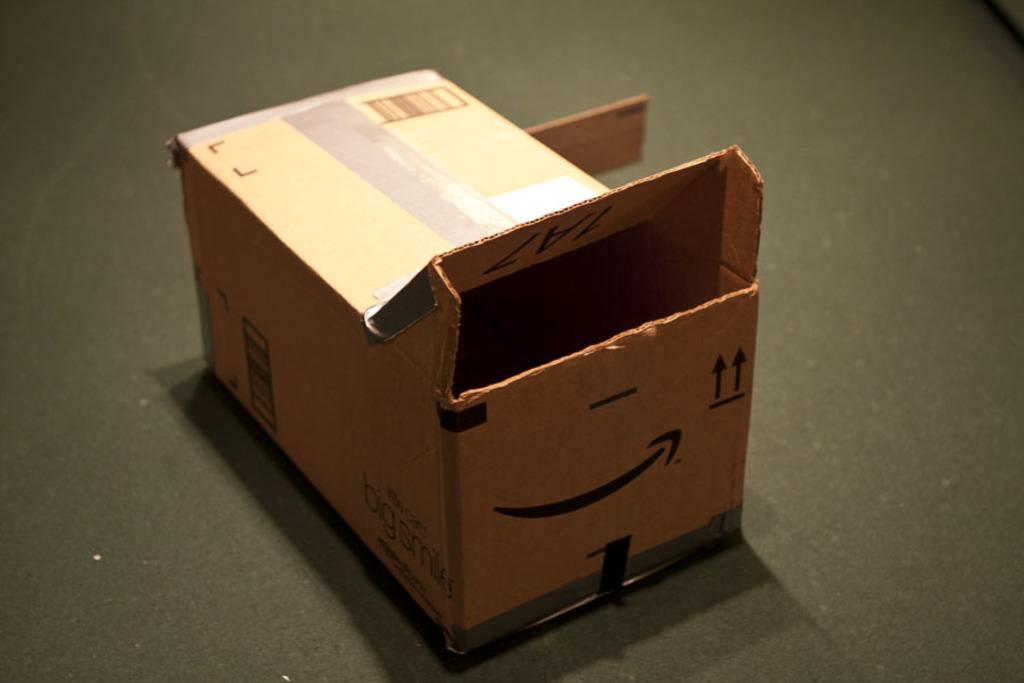What object is present in the image that is made of cardboard? There is a cardboard box in the image. What is the cardboard box placed on in the image? The cardboard box is kept on a black surface. How many hens can be seen playing in the sand near the cardboard box in the image? There are no hens or sand present in the image; it only features a cardboard box on a black surface. 